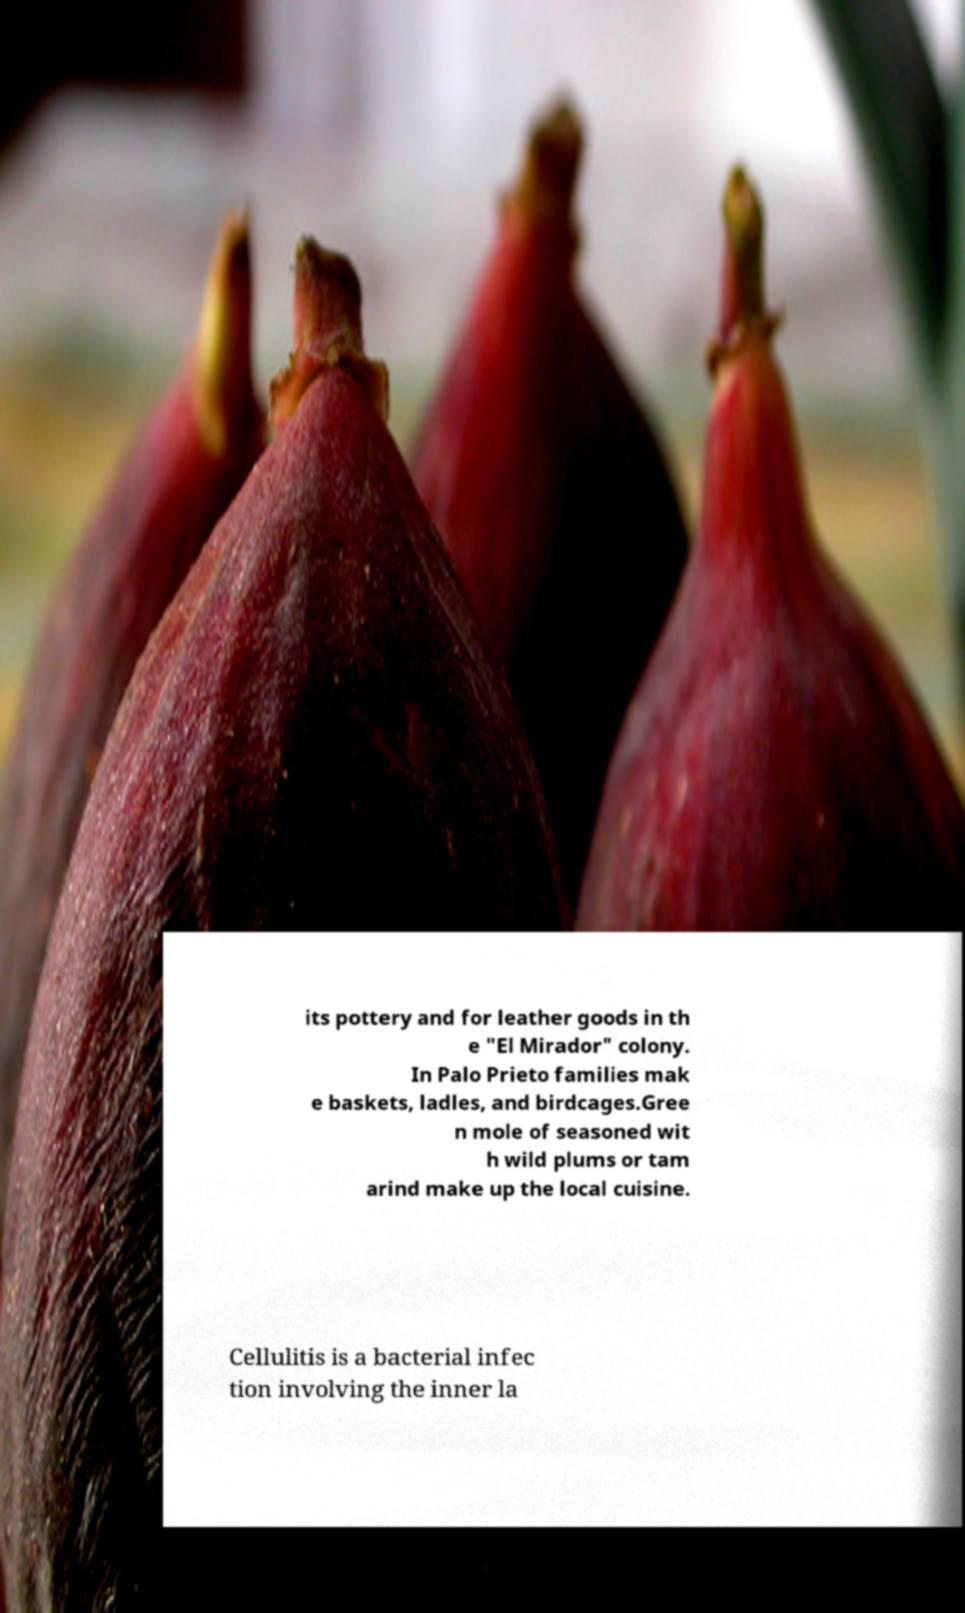There's text embedded in this image that I need extracted. Can you transcribe it verbatim? its pottery and for leather goods in th e "El Mirador" colony. In Palo Prieto families mak e baskets, ladles, and birdcages.Gree n mole of seasoned wit h wild plums or tam arind make up the local cuisine. Cellulitis is a bacterial infec tion involving the inner la 